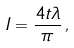<formula> <loc_0><loc_0><loc_500><loc_500>I = \frac { 4 t \lambda } { \pi } \, ,</formula> 